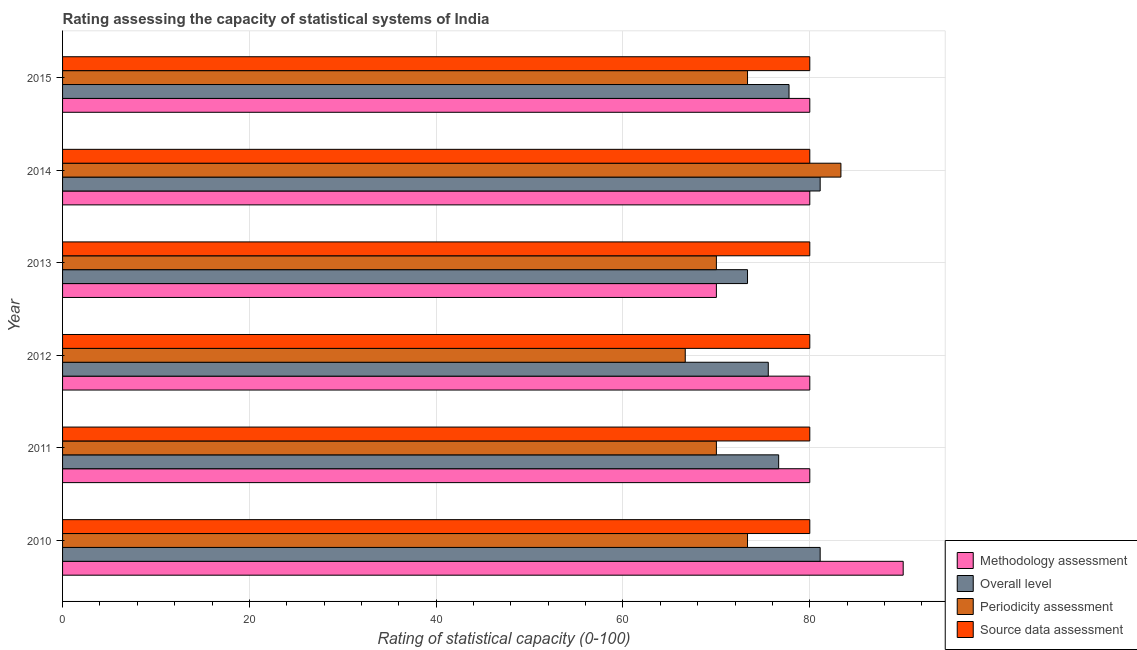How many different coloured bars are there?
Offer a very short reply. 4. Are the number of bars per tick equal to the number of legend labels?
Make the answer very short. Yes. Are the number of bars on each tick of the Y-axis equal?
Give a very brief answer. Yes. How many bars are there on the 4th tick from the top?
Offer a very short reply. 4. How many bars are there on the 3rd tick from the bottom?
Keep it short and to the point. 4. What is the label of the 2nd group of bars from the top?
Offer a terse response. 2014. In how many cases, is the number of bars for a given year not equal to the number of legend labels?
Provide a succinct answer. 0. What is the overall level rating in 2010?
Offer a terse response. 81.11. Across all years, what is the maximum periodicity assessment rating?
Give a very brief answer. 83.33. Across all years, what is the minimum periodicity assessment rating?
Keep it short and to the point. 66.67. In which year was the periodicity assessment rating minimum?
Your answer should be compact. 2012. What is the total periodicity assessment rating in the graph?
Ensure brevity in your answer.  436.67. What is the difference between the source data assessment rating in 2010 and that in 2015?
Provide a succinct answer. 0. What is the difference between the overall level rating in 2012 and the source data assessment rating in 2010?
Keep it short and to the point. -4.44. In the year 2011, what is the difference between the periodicity assessment rating and source data assessment rating?
Offer a very short reply. -10. In how many years, is the periodicity assessment rating greater than 64 ?
Ensure brevity in your answer.  6. What is the ratio of the source data assessment rating in 2014 to that in 2015?
Provide a succinct answer. 1. Is the periodicity assessment rating in 2010 less than that in 2012?
Ensure brevity in your answer.  No. What is the difference between the highest and the lowest overall level rating?
Your response must be concise. 7.78. Is the sum of the source data assessment rating in 2011 and 2012 greater than the maximum methodology assessment rating across all years?
Offer a very short reply. Yes. Is it the case that in every year, the sum of the overall level rating and source data assessment rating is greater than the sum of methodology assessment rating and periodicity assessment rating?
Your answer should be compact. No. What does the 2nd bar from the top in 2014 represents?
Your response must be concise. Periodicity assessment. What does the 3rd bar from the bottom in 2013 represents?
Offer a very short reply. Periodicity assessment. How many bars are there?
Provide a short and direct response. 24. Are all the bars in the graph horizontal?
Ensure brevity in your answer.  Yes. How are the legend labels stacked?
Your answer should be compact. Vertical. What is the title of the graph?
Ensure brevity in your answer.  Rating assessing the capacity of statistical systems of India. Does "Overall level" appear as one of the legend labels in the graph?
Provide a short and direct response. Yes. What is the label or title of the X-axis?
Provide a short and direct response. Rating of statistical capacity (0-100). What is the Rating of statistical capacity (0-100) of Methodology assessment in 2010?
Your answer should be compact. 90. What is the Rating of statistical capacity (0-100) in Overall level in 2010?
Your response must be concise. 81.11. What is the Rating of statistical capacity (0-100) in Periodicity assessment in 2010?
Offer a very short reply. 73.33. What is the Rating of statistical capacity (0-100) in Source data assessment in 2010?
Make the answer very short. 80. What is the Rating of statistical capacity (0-100) in Overall level in 2011?
Give a very brief answer. 76.67. What is the Rating of statistical capacity (0-100) in Periodicity assessment in 2011?
Offer a terse response. 70. What is the Rating of statistical capacity (0-100) in Overall level in 2012?
Give a very brief answer. 75.56. What is the Rating of statistical capacity (0-100) in Periodicity assessment in 2012?
Your answer should be compact. 66.67. What is the Rating of statistical capacity (0-100) in Source data assessment in 2012?
Give a very brief answer. 80. What is the Rating of statistical capacity (0-100) of Methodology assessment in 2013?
Ensure brevity in your answer.  70. What is the Rating of statistical capacity (0-100) in Overall level in 2013?
Your answer should be compact. 73.33. What is the Rating of statistical capacity (0-100) in Overall level in 2014?
Make the answer very short. 81.11. What is the Rating of statistical capacity (0-100) in Periodicity assessment in 2014?
Give a very brief answer. 83.33. What is the Rating of statistical capacity (0-100) in Overall level in 2015?
Your answer should be very brief. 77.78. What is the Rating of statistical capacity (0-100) of Periodicity assessment in 2015?
Your response must be concise. 73.33. Across all years, what is the maximum Rating of statistical capacity (0-100) in Overall level?
Offer a very short reply. 81.11. Across all years, what is the maximum Rating of statistical capacity (0-100) of Periodicity assessment?
Make the answer very short. 83.33. Across all years, what is the maximum Rating of statistical capacity (0-100) in Source data assessment?
Give a very brief answer. 80. Across all years, what is the minimum Rating of statistical capacity (0-100) in Methodology assessment?
Keep it short and to the point. 70. Across all years, what is the minimum Rating of statistical capacity (0-100) of Overall level?
Offer a very short reply. 73.33. Across all years, what is the minimum Rating of statistical capacity (0-100) in Periodicity assessment?
Your answer should be very brief. 66.67. Across all years, what is the minimum Rating of statistical capacity (0-100) of Source data assessment?
Provide a short and direct response. 80. What is the total Rating of statistical capacity (0-100) of Methodology assessment in the graph?
Ensure brevity in your answer.  480. What is the total Rating of statistical capacity (0-100) of Overall level in the graph?
Give a very brief answer. 465.56. What is the total Rating of statistical capacity (0-100) in Periodicity assessment in the graph?
Give a very brief answer. 436.67. What is the total Rating of statistical capacity (0-100) of Source data assessment in the graph?
Your response must be concise. 480. What is the difference between the Rating of statistical capacity (0-100) in Methodology assessment in 2010 and that in 2011?
Your response must be concise. 10. What is the difference between the Rating of statistical capacity (0-100) of Overall level in 2010 and that in 2011?
Give a very brief answer. 4.44. What is the difference between the Rating of statistical capacity (0-100) in Periodicity assessment in 2010 and that in 2011?
Provide a succinct answer. 3.33. What is the difference between the Rating of statistical capacity (0-100) in Overall level in 2010 and that in 2012?
Your answer should be compact. 5.56. What is the difference between the Rating of statistical capacity (0-100) of Methodology assessment in 2010 and that in 2013?
Your answer should be compact. 20. What is the difference between the Rating of statistical capacity (0-100) of Overall level in 2010 and that in 2013?
Your answer should be compact. 7.78. What is the difference between the Rating of statistical capacity (0-100) of Source data assessment in 2010 and that in 2013?
Offer a terse response. 0. What is the difference between the Rating of statistical capacity (0-100) of Methodology assessment in 2010 and that in 2014?
Ensure brevity in your answer.  10. What is the difference between the Rating of statistical capacity (0-100) in Source data assessment in 2010 and that in 2014?
Give a very brief answer. 0. What is the difference between the Rating of statistical capacity (0-100) in Methodology assessment in 2010 and that in 2015?
Offer a very short reply. 10. What is the difference between the Rating of statistical capacity (0-100) of Periodicity assessment in 2010 and that in 2015?
Provide a succinct answer. -0. What is the difference between the Rating of statistical capacity (0-100) in Methodology assessment in 2011 and that in 2012?
Provide a succinct answer. 0. What is the difference between the Rating of statistical capacity (0-100) in Overall level in 2011 and that in 2012?
Keep it short and to the point. 1.11. What is the difference between the Rating of statistical capacity (0-100) of Periodicity assessment in 2011 and that in 2012?
Make the answer very short. 3.33. What is the difference between the Rating of statistical capacity (0-100) in Source data assessment in 2011 and that in 2012?
Your answer should be compact. 0. What is the difference between the Rating of statistical capacity (0-100) of Periodicity assessment in 2011 and that in 2013?
Provide a succinct answer. 0. What is the difference between the Rating of statistical capacity (0-100) in Source data assessment in 2011 and that in 2013?
Offer a very short reply. 0. What is the difference between the Rating of statistical capacity (0-100) in Overall level in 2011 and that in 2014?
Keep it short and to the point. -4.44. What is the difference between the Rating of statistical capacity (0-100) in Periodicity assessment in 2011 and that in 2014?
Keep it short and to the point. -13.33. What is the difference between the Rating of statistical capacity (0-100) in Overall level in 2011 and that in 2015?
Keep it short and to the point. -1.11. What is the difference between the Rating of statistical capacity (0-100) in Periodicity assessment in 2011 and that in 2015?
Provide a succinct answer. -3.33. What is the difference between the Rating of statistical capacity (0-100) of Source data assessment in 2011 and that in 2015?
Your answer should be compact. 0. What is the difference between the Rating of statistical capacity (0-100) in Methodology assessment in 2012 and that in 2013?
Keep it short and to the point. 10. What is the difference between the Rating of statistical capacity (0-100) in Overall level in 2012 and that in 2013?
Your response must be concise. 2.22. What is the difference between the Rating of statistical capacity (0-100) in Source data assessment in 2012 and that in 2013?
Your answer should be compact. 0. What is the difference between the Rating of statistical capacity (0-100) in Overall level in 2012 and that in 2014?
Your answer should be very brief. -5.56. What is the difference between the Rating of statistical capacity (0-100) in Periodicity assessment in 2012 and that in 2014?
Your answer should be very brief. -16.67. What is the difference between the Rating of statistical capacity (0-100) of Methodology assessment in 2012 and that in 2015?
Keep it short and to the point. 0. What is the difference between the Rating of statistical capacity (0-100) in Overall level in 2012 and that in 2015?
Keep it short and to the point. -2.22. What is the difference between the Rating of statistical capacity (0-100) in Periodicity assessment in 2012 and that in 2015?
Offer a very short reply. -6.67. What is the difference between the Rating of statistical capacity (0-100) of Overall level in 2013 and that in 2014?
Offer a very short reply. -7.78. What is the difference between the Rating of statistical capacity (0-100) of Periodicity assessment in 2013 and that in 2014?
Provide a succinct answer. -13.33. What is the difference between the Rating of statistical capacity (0-100) of Source data assessment in 2013 and that in 2014?
Offer a very short reply. 0. What is the difference between the Rating of statistical capacity (0-100) in Methodology assessment in 2013 and that in 2015?
Your answer should be very brief. -10. What is the difference between the Rating of statistical capacity (0-100) of Overall level in 2013 and that in 2015?
Provide a succinct answer. -4.44. What is the difference between the Rating of statistical capacity (0-100) of Periodicity assessment in 2013 and that in 2015?
Give a very brief answer. -3.33. What is the difference between the Rating of statistical capacity (0-100) in Overall level in 2014 and that in 2015?
Offer a terse response. 3.33. What is the difference between the Rating of statistical capacity (0-100) of Periodicity assessment in 2014 and that in 2015?
Keep it short and to the point. 10. What is the difference between the Rating of statistical capacity (0-100) in Methodology assessment in 2010 and the Rating of statistical capacity (0-100) in Overall level in 2011?
Offer a terse response. 13.33. What is the difference between the Rating of statistical capacity (0-100) of Methodology assessment in 2010 and the Rating of statistical capacity (0-100) of Periodicity assessment in 2011?
Your answer should be very brief. 20. What is the difference between the Rating of statistical capacity (0-100) of Overall level in 2010 and the Rating of statistical capacity (0-100) of Periodicity assessment in 2011?
Provide a short and direct response. 11.11. What is the difference between the Rating of statistical capacity (0-100) in Periodicity assessment in 2010 and the Rating of statistical capacity (0-100) in Source data assessment in 2011?
Ensure brevity in your answer.  -6.67. What is the difference between the Rating of statistical capacity (0-100) in Methodology assessment in 2010 and the Rating of statistical capacity (0-100) in Overall level in 2012?
Give a very brief answer. 14.44. What is the difference between the Rating of statistical capacity (0-100) of Methodology assessment in 2010 and the Rating of statistical capacity (0-100) of Periodicity assessment in 2012?
Ensure brevity in your answer.  23.33. What is the difference between the Rating of statistical capacity (0-100) in Overall level in 2010 and the Rating of statistical capacity (0-100) in Periodicity assessment in 2012?
Give a very brief answer. 14.44. What is the difference between the Rating of statistical capacity (0-100) of Periodicity assessment in 2010 and the Rating of statistical capacity (0-100) of Source data assessment in 2012?
Your response must be concise. -6.67. What is the difference between the Rating of statistical capacity (0-100) of Methodology assessment in 2010 and the Rating of statistical capacity (0-100) of Overall level in 2013?
Make the answer very short. 16.67. What is the difference between the Rating of statistical capacity (0-100) of Methodology assessment in 2010 and the Rating of statistical capacity (0-100) of Source data assessment in 2013?
Give a very brief answer. 10. What is the difference between the Rating of statistical capacity (0-100) of Overall level in 2010 and the Rating of statistical capacity (0-100) of Periodicity assessment in 2013?
Offer a very short reply. 11.11. What is the difference between the Rating of statistical capacity (0-100) in Overall level in 2010 and the Rating of statistical capacity (0-100) in Source data assessment in 2013?
Your answer should be very brief. 1.11. What is the difference between the Rating of statistical capacity (0-100) of Periodicity assessment in 2010 and the Rating of statistical capacity (0-100) of Source data assessment in 2013?
Provide a short and direct response. -6.67. What is the difference between the Rating of statistical capacity (0-100) in Methodology assessment in 2010 and the Rating of statistical capacity (0-100) in Overall level in 2014?
Offer a terse response. 8.89. What is the difference between the Rating of statistical capacity (0-100) of Overall level in 2010 and the Rating of statistical capacity (0-100) of Periodicity assessment in 2014?
Provide a succinct answer. -2.22. What is the difference between the Rating of statistical capacity (0-100) of Overall level in 2010 and the Rating of statistical capacity (0-100) of Source data assessment in 2014?
Keep it short and to the point. 1.11. What is the difference between the Rating of statistical capacity (0-100) of Periodicity assessment in 2010 and the Rating of statistical capacity (0-100) of Source data assessment in 2014?
Provide a short and direct response. -6.67. What is the difference between the Rating of statistical capacity (0-100) in Methodology assessment in 2010 and the Rating of statistical capacity (0-100) in Overall level in 2015?
Offer a very short reply. 12.22. What is the difference between the Rating of statistical capacity (0-100) in Methodology assessment in 2010 and the Rating of statistical capacity (0-100) in Periodicity assessment in 2015?
Provide a short and direct response. 16.67. What is the difference between the Rating of statistical capacity (0-100) in Methodology assessment in 2010 and the Rating of statistical capacity (0-100) in Source data assessment in 2015?
Your answer should be very brief. 10. What is the difference between the Rating of statistical capacity (0-100) in Overall level in 2010 and the Rating of statistical capacity (0-100) in Periodicity assessment in 2015?
Keep it short and to the point. 7.78. What is the difference between the Rating of statistical capacity (0-100) in Periodicity assessment in 2010 and the Rating of statistical capacity (0-100) in Source data assessment in 2015?
Provide a succinct answer. -6.67. What is the difference between the Rating of statistical capacity (0-100) in Methodology assessment in 2011 and the Rating of statistical capacity (0-100) in Overall level in 2012?
Offer a terse response. 4.44. What is the difference between the Rating of statistical capacity (0-100) in Methodology assessment in 2011 and the Rating of statistical capacity (0-100) in Periodicity assessment in 2012?
Offer a terse response. 13.33. What is the difference between the Rating of statistical capacity (0-100) in Methodology assessment in 2011 and the Rating of statistical capacity (0-100) in Source data assessment in 2012?
Ensure brevity in your answer.  0. What is the difference between the Rating of statistical capacity (0-100) in Overall level in 2011 and the Rating of statistical capacity (0-100) in Periodicity assessment in 2012?
Make the answer very short. 10. What is the difference between the Rating of statistical capacity (0-100) of Overall level in 2011 and the Rating of statistical capacity (0-100) of Source data assessment in 2012?
Provide a succinct answer. -3.33. What is the difference between the Rating of statistical capacity (0-100) of Methodology assessment in 2011 and the Rating of statistical capacity (0-100) of Overall level in 2013?
Provide a short and direct response. 6.67. What is the difference between the Rating of statistical capacity (0-100) of Methodology assessment in 2011 and the Rating of statistical capacity (0-100) of Overall level in 2014?
Your answer should be compact. -1.11. What is the difference between the Rating of statistical capacity (0-100) of Overall level in 2011 and the Rating of statistical capacity (0-100) of Periodicity assessment in 2014?
Your response must be concise. -6.67. What is the difference between the Rating of statistical capacity (0-100) of Periodicity assessment in 2011 and the Rating of statistical capacity (0-100) of Source data assessment in 2014?
Offer a terse response. -10. What is the difference between the Rating of statistical capacity (0-100) of Methodology assessment in 2011 and the Rating of statistical capacity (0-100) of Overall level in 2015?
Offer a terse response. 2.22. What is the difference between the Rating of statistical capacity (0-100) of Methodology assessment in 2011 and the Rating of statistical capacity (0-100) of Periodicity assessment in 2015?
Provide a succinct answer. 6.67. What is the difference between the Rating of statistical capacity (0-100) in Methodology assessment in 2011 and the Rating of statistical capacity (0-100) in Source data assessment in 2015?
Offer a terse response. 0. What is the difference between the Rating of statistical capacity (0-100) in Overall level in 2011 and the Rating of statistical capacity (0-100) in Periodicity assessment in 2015?
Your answer should be compact. 3.33. What is the difference between the Rating of statistical capacity (0-100) in Overall level in 2011 and the Rating of statistical capacity (0-100) in Source data assessment in 2015?
Ensure brevity in your answer.  -3.33. What is the difference between the Rating of statistical capacity (0-100) in Periodicity assessment in 2011 and the Rating of statistical capacity (0-100) in Source data assessment in 2015?
Your answer should be very brief. -10. What is the difference between the Rating of statistical capacity (0-100) of Methodology assessment in 2012 and the Rating of statistical capacity (0-100) of Source data assessment in 2013?
Give a very brief answer. 0. What is the difference between the Rating of statistical capacity (0-100) of Overall level in 2012 and the Rating of statistical capacity (0-100) of Periodicity assessment in 2013?
Give a very brief answer. 5.56. What is the difference between the Rating of statistical capacity (0-100) of Overall level in 2012 and the Rating of statistical capacity (0-100) of Source data assessment in 2013?
Make the answer very short. -4.44. What is the difference between the Rating of statistical capacity (0-100) of Periodicity assessment in 2012 and the Rating of statistical capacity (0-100) of Source data assessment in 2013?
Offer a very short reply. -13.33. What is the difference between the Rating of statistical capacity (0-100) of Methodology assessment in 2012 and the Rating of statistical capacity (0-100) of Overall level in 2014?
Your response must be concise. -1.11. What is the difference between the Rating of statistical capacity (0-100) in Methodology assessment in 2012 and the Rating of statistical capacity (0-100) in Periodicity assessment in 2014?
Make the answer very short. -3.33. What is the difference between the Rating of statistical capacity (0-100) in Methodology assessment in 2012 and the Rating of statistical capacity (0-100) in Source data assessment in 2014?
Provide a succinct answer. 0. What is the difference between the Rating of statistical capacity (0-100) in Overall level in 2012 and the Rating of statistical capacity (0-100) in Periodicity assessment in 2014?
Your answer should be very brief. -7.78. What is the difference between the Rating of statistical capacity (0-100) in Overall level in 2012 and the Rating of statistical capacity (0-100) in Source data assessment in 2014?
Offer a very short reply. -4.44. What is the difference between the Rating of statistical capacity (0-100) of Periodicity assessment in 2012 and the Rating of statistical capacity (0-100) of Source data assessment in 2014?
Provide a succinct answer. -13.33. What is the difference between the Rating of statistical capacity (0-100) of Methodology assessment in 2012 and the Rating of statistical capacity (0-100) of Overall level in 2015?
Keep it short and to the point. 2.22. What is the difference between the Rating of statistical capacity (0-100) of Methodology assessment in 2012 and the Rating of statistical capacity (0-100) of Periodicity assessment in 2015?
Provide a short and direct response. 6.67. What is the difference between the Rating of statistical capacity (0-100) in Methodology assessment in 2012 and the Rating of statistical capacity (0-100) in Source data assessment in 2015?
Offer a terse response. 0. What is the difference between the Rating of statistical capacity (0-100) of Overall level in 2012 and the Rating of statistical capacity (0-100) of Periodicity assessment in 2015?
Your answer should be compact. 2.22. What is the difference between the Rating of statistical capacity (0-100) of Overall level in 2012 and the Rating of statistical capacity (0-100) of Source data assessment in 2015?
Offer a terse response. -4.44. What is the difference between the Rating of statistical capacity (0-100) in Periodicity assessment in 2012 and the Rating of statistical capacity (0-100) in Source data assessment in 2015?
Offer a very short reply. -13.33. What is the difference between the Rating of statistical capacity (0-100) in Methodology assessment in 2013 and the Rating of statistical capacity (0-100) in Overall level in 2014?
Ensure brevity in your answer.  -11.11. What is the difference between the Rating of statistical capacity (0-100) of Methodology assessment in 2013 and the Rating of statistical capacity (0-100) of Periodicity assessment in 2014?
Your answer should be very brief. -13.33. What is the difference between the Rating of statistical capacity (0-100) in Overall level in 2013 and the Rating of statistical capacity (0-100) in Periodicity assessment in 2014?
Keep it short and to the point. -10. What is the difference between the Rating of statistical capacity (0-100) in Overall level in 2013 and the Rating of statistical capacity (0-100) in Source data assessment in 2014?
Offer a terse response. -6.67. What is the difference between the Rating of statistical capacity (0-100) of Methodology assessment in 2013 and the Rating of statistical capacity (0-100) of Overall level in 2015?
Your answer should be very brief. -7.78. What is the difference between the Rating of statistical capacity (0-100) of Methodology assessment in 2013 and the Rating of statistical capacity (0-100) of Periodicity assessment in 2015?
Offer a terse response. -3.33. What is the difference between the Rating of statistical capacity (0-100) of Methodology assessment in 2013 and the Rating of statistical capacity (0-100) of Source data assessment in 2015?
Your answer should be compact. -10. What is the difference between the Rating of statistical capacity (0-100) in Overall level in 2013 and the Rating of statistical capacity (0-100) in Periodicity assessment in 2015?
Your answer should be very brief. -0. What is the difference between the Rating of statistical capacity (0-100) in Overall level in 2013 and the Rating of statistical capacity (0-100) in Source data assessment in 2015?
Provide a succinct answer. -6.67. What is the difference between the Rating of statistical capacity (0-100) in Methodology assessment in 2014 and the Rating of statistical capacity (0-100) in Overall level in 2015?
Your response must be concise. 2.22. What is the difference between the Rating of statistical capacity (0-100) in Methodology assessment in 2014 and the Rating of statistical capacity (0-100) in Periodicity assessment in 2015?
Make the answer very short. 6.67. What is the difference between the Rating of statistical capacity (0-100) of Methodology assessment in 2014 and the Rating of statistical capacity (0-100) of Source data assessment in 2015?
Provide a short and direct response. 0. What is the difference between the Rating of statistical capacity (0-100) in Overall level in 2014 and the Rating of statistical capacity (0-100) in Periodicity assessment in 2015?
Your response must be concise. 7.78. What is the difference between the Rating of statistical capacity (0-100) in Overall level in 2014 and the Rating of statistical capacity (0-100) in Source data assessment in 2015?
Provide a succinct answer. 1.11. What is the difference between the Rating of statistical capacity (0-100) in Periodicity assessment in 2014 and the Rating of statistical capacity (0-100) in Source data assessment in 2015?
Provide a succinct answer. 3.33. What is the average Rating of statistical capacity (0-100) of Methodology assessment per year?
Make the answer very short. 80. What is the average Rating of statistical capacity (0-100) in Overall level per year?
Offer a terse response. 77.59. What is the average Rating of statistical capacity (0-100) of Periodicity assessment per year?
Your answer should be compact. 72.78. What is the average Rating of statistical capacity (0-100) of Source data assessment per year?
Your response must be concise. 80. In the year 2010, what is the difference between the Rating of statistical capacity (0-100) in Methodology assessment and Rating of statistical capacity (0-100) in Overall level?
Your answer should be compact. 8.89. In the year 2010, what is the difference between the Rating of statistical capacity (0-100) in Methodology assessment and Rating of statistical capacity (0-100) in Periodicity assessment?
Offer a terse response. 16.67. In the year 2010, what is the difference between the Rating of statistical capacity (0-100) of Methodology assessment and Rating of statistical capacity (0-100) of Source data assessment?
Your answer should be compact. 10. In the year 2010, what is the difference between the Rating of statistical capacity (0-100) of Overall level and Rating of statistical capacity (0-100) of Periodicity assessment?
Provide a short and direct response. 7.78. In the year 2010, what is the difference between the Rating of statistical capacity (0-100) in Overall level and Rating of statistical capacity (0-100) in Source data assessment?
Provide a short and direct response. 1.11. In the year 2010, what is the difference between the Rating of statistical capacity (0-100) of Periodicity assessment and Rating of statistical capacity (0-100) of Source data assessment?
Offer a terse response. -6.67. In the year 2011, what is the difference between the Rating of statistical capacity (0-100) in Methodology assessment and Rating of statistical capacity (0-100) in Overall level?
Your answer should be compact. 3.33. In the year 2011, what is the difference between the Rating of statistical capacity (0-100) of Methodology assessment and Rating of statistical capacity (0-100) of Periodicity assessment?
Give a very brief answer. 10. In the year 2011, what is the difference between the Rating of statistical capacity (0-100) of Methodology assessment and Rating of statistical capacity (0-100) of Source data assessment?
Provide a succinct answer. 0. In the year 2011, what is the difference between the Rating of statistical capacity (0-100) of Periodicity assessment and Rating of statistical capacity (0-100) of Source data assessment?
Offer a very short reply. -10. In the year 2012, what is the difference between the Rating of statistical capacity (0-100) of Methodology assessment and Rating of statistical capacity (0-100) of Overall level?
Your response must be concise. 4.44. In the year 2012, what is the difference between the Rating of statistical capacity (0-100) in Methodology assessment and Rating of statistical capacity (0-100) in Periodicity assessment?
Provide a succinct answer. 13.33. In the year 2012, what is the difference between the Rating of statistical capacity (0-100) in Methodology assessment and Rating of statistical capacity (0-100) in Source data assessment?
Make the answer very short. 0. In the year 2012, what is the difference between the Rating of statistical capacity (0-100) in Overall level and Rating of statistical capacity (0-100) in Periodicity assessment?
Your answer should be compact. 8.89. In the year 2012, what is the difference between the Rating of statistical capacity (0-100) in Overall level and Rating of statistical capacity (0-100) in Source data assessment?
Offer a very short reply. -4.44. In the year 2012, what is the difference between the Rating of statistical capacity (0-100) in Periodicity assessment and Rating of statistical capacity (0-100) in Source data assessment?
Ensure brevity in your answer.  -13.33. In the year 2013, what is the difference between the Rating of statistical capacity (0-100) of Methodology assessment and Rating of statistical capacity (0-100) of Periodicity assessment?
Your answer should be very brief. 0. In the year 2013, what is the difference between the Rating of statistical capacity (0-100) of Overall level and Rating of statistical capacity (0-100) of Source data assessment?
Offer a very short reply. -6.67. In the year 2013, what is the difference between the Rating of statistical capacity (0-100) in Periodicity assessment and Rating of statistical capacity (0-100) in Source data assessment?
Offer a very short reply. -10. In the year 2014, what is the difference between the Rating of statistical capacity (0-100) of Methodology assessment and Rating of statistical capacity (0-100) of Overall level?
Ensure brevity in your answer.  -1.11. In the year 2014, what is the difference between the Rating of statistical capacity (0-100) in Methodology assessment and Rating of statistical capacity (0-100) in Source data assessment?
Your response must be concise. 0. In the year 2014, what is the difference between the Rating of statistical capacity (0-100) in Overall level and Rating of statistical capacity (0-100) in Periodicity assessment?
Your answer should be very brief. -2.22. In the year 2015, what is the difference between the Rating of statistical capacity (0-100) of Methodology assessment and Rating of statistical capacity (0-100) of Overall level?
Ensure brevity in your answer.  2.22. In the year 2015, what is the difference between the Rating of statistical capacity (0-100) in Methodology assessment and Rating of statistical capacity (0-100) in Periodicity assessment?
Give a very brief answer. 6.67. In the year 2015, what is the difference between the Rating of statistical capacity (0-100) in Methodology assessment and Rating of statistical capacity (0-100) in Source data assessment?
Offer a very short reply. 0. In the year 2015, what is the difference between the Rating of statistical capacity (0-100) in Overall level and Rating of statistical capacity (0-100) in Periodicity assessment?
Ensure brevity in your answer.  4.44. In the year 2015, what is the difference between the Rating of statistical capacity (0-100) in Overall level and Rating of statistical capacity (0-100) in Source data assessment?
Your answer should be compact. -2.22. In the year 2015, what is the difference between the Rating of statistical capacity (0-100) of Periodicity assessment and Rating of statistical capacity (0-100) of Source data assessment?
Offer a terse response. -6.67. What is the ratio of the Rating of statistical capacity (0-100) of Overall level in 2010 to that in 2011?
Keep it short and to the point. 1.06. What is the ratio of the Rating of statistical capacity (0-100) in Periodicity assessment in 2010 to that in 2011?
Your response must be concise. 1.05. What is the ratio of the Rating of statistical capacity (0-100) of Overall level in 2010 to that in 2012?
Offer a terse response. 1.07. What is the ratio of the Rating of statistical capacity (0-100) in Source data assessment in 2010 to that in 2012?
Your answer should be compact. 1. What is the ratio of the Rating of statistical capacity (0-100) of Methodology assessment in 2010 to that in 2013?
Your answer should be compact. 1.29. What is the ratio of the Rating of statistical capacity (0-100) of Overall level in 2010 to that in 2013?
Provide a short and direct response. 1.11. What is the ratio of the Rating of statistical capacity (0-100) in Periodicity assessment in 2010 to that in 2013?
Provide a short and direct response. 1.05. What is the ratio of the Rating of statistical capacity (0-100) of Periodicity assessment in 2010 to that in 2014?
Your answer should be very brief. 0.88. What is the ratio of the Rating of statistical capacity (0-100) of Source data assessment in 2010 to that in 2014?
Your answer should be very brief. 1. What is the ratio of the Rating of statistical capacity (0-100) in Overall level in 2010 to that in 2015?
Ensure brevity in your answer.  1.04. What is the ratio of the Rating of statistical capacity (0-100) in Periodicity assessment in 2010 to that in 2015?
Give a very brief answer. 1. What is the ratio of the Rating of statistical capacity (0-100) in Source data assessment in 2010 to that in 2015?
Make the answer very short. 1. What is the ratio of the Rating of statistical capacity (0-100) of Methodology assessment in 2011 to that in 2012?
Give a very brief answer. 1. What is the ratio of the Rating of statistical capacity (0-100) of Overall level in 2011 to that in 2012?
Ensure brevity in your answer.  1.01. What is the ratio of the Rating of statistical capacity (0-100) of Periodicity assessment in 2011 to that in 2012?
Your response must be concise. 1.05. What is the ratio of the Rating of statistical capacity (0-100) of Source data assessment in 2011 to that in 2012?
Provide a short and direct response. 1. What is the ratio of the Rating of statistical capacity (0-100) in Methodology assessment in 2011 to that in 2013?
Keep it short and to the point. 1.14. What is the ratio of the Rating of statistical capacity (0-100) of Overall level in 2011 to that in 2013?
Ensure brevity in your answer.  1.05. What is the ratio of the Rating of statistical capacity (0-100) of Periodicity assessment in 2011 to that in 2013?
Make the answer very short. 1. What is the ratio of the Rating of statistical capacity (0-100) in Overall level in 2011 to that in 2014?
Give a very brief answer. 0.95. What is the ratio of the Rating of statistical capacity (0-100) of Periodicity assessment in 2011 to that in 2014?
Offer a very short reply. 0.84. What is the ratio of the Rating of statistical capacity (0-100) in Source data assessment in 2011 to that in 2014?
Keep it short and to the point. 1. What is the ratio of the Rating of statistical capacity (0-100) in Overall level in 2011 to that in 2015?
Make the answer very short. 0.99. What is the ratio of the Rating of statistical capacity (0-100) of Periodicity assessment in 2011 to that in 2015?
Your answer should be compact. 0.95. What is the ratio of the Rating of statistical capacity (0-100) in Source data assessment in 2011 to that in 2015?
Provide a short and direct response. 1. What is the ratio of the Rating of statistical capacity (0-100) in Methodology assessment in 2012 to that in 2013?
Your answer should be compact. 1.14. What is the ratio of the Rating of statistical capacity (0-100) in Overall level in 2012 to that in 2013?
Your response must be concise. 1.03. What is the ratio of the Rating of statistical capacity (0-100) of Source data assessment in 2012 to that in 2013?
Give a very brief answer. 1. What is the ratio of the Rating of statistical capacity (0-100) in Overall level in 2012 to that in 2014?
Provide a short and direct response. 0.93. What is the ratio of the Rating of statistical capacity (0-100) in Source data assessment in 2012 to that in 2014?
Provide a succinct answer. 1. What is the ratio of the Rating of statistical capacity (0-100) in Methodology assessment in 2012 to that in 2015?
Offer a terse response. 1. What is the ratio of the Rating of statistical capacity (0-100) in Overall level in 2012 to that in 2015?
Your answer should be very brief. 0.97. What is the ratio of the Rating of statistical capacity (0-100) of Periodicity assessment in 2012 to that in 2015?
Make the answer very short. 0.91. What is the ratio of the Rating of statistical capacity (0-100) of Source data assessment in 2012 to that in 2015?
Provide a succinct answer. 1. What is the ratio of the Rating of statistical capacity (0-100) in Overall level in 2013 to that in 2014?
Your response must be concise. 0.9. What is the ratio of the Rating of statistical capacity (0-100) of Periodicity assessment in 2013 to that in 2014?
Keep it short and to the point. 0.84. What is the ratio of the Rating of statistical capacity (0-100) of Source data assessment in 2013 to that in 2014?
Make the answer very short. 1. What is the ratio of the Rating of statistical capacity (0-100) in Overall level in 2013 to that in 2015?
Keep it short and to the point. 0.94. What is the ratio of the Rating of statistical capacity (0-100) of Periodicity assessment in 2013 to that in 2015?
Your answer should be compact. 0.95. What is the ratio of the Rating of statistical capacity (0-100) in Source data assessment in 2013 to that in 2015?
Keep it short and to the point. 1. What is the ratio of the Rating of statistical capacity (0-100) in Methodology assessment in 2014 to that in 2015?
Make the answer very short. 1. What is the ratio of the Rating of statistical capacity (0-100) of Overall level in 2014 to that in 2015?
Make the answer very short. 1.04. What is the ratio of the Rating of statistical capacity (0-100) in Periodicity assessment in 2014 to that in 2015?
Your answer should be very brief. 1.14. What is the ratio of the Rating of statistical capacity (0-100) in Source data assessment in 2014 to that in 2015?
Your answer should be very brief. 1. What is the difference between the highest and the second highest Rating of statistical capacity (0-100) of Overall level?
Offer a terse response. 0. What is the difference between the highest and the second highest Rating of statistical capacity (0-100) in Periodicity assessment?
Make the answer very short. 10. What is the difference between the highest and the second highest Rating of statistical capacity (0-100) of Source data assessment?
Offer a terse response. 0. What is the difference between the highest and the lowest Rating of statistical capacity (0-100) in Overall level?
Your response must be concise. 7.78. What is the difference between the highest and the lowest Rating of statistical capacity (0-100) of Periodicity assessment?
Your answer should be compact. 16.67. What is the difference between the highest and the lowest Rating of statistical capacity (0-100) of Source data assessment?
Provide a succinct answer. 0. 